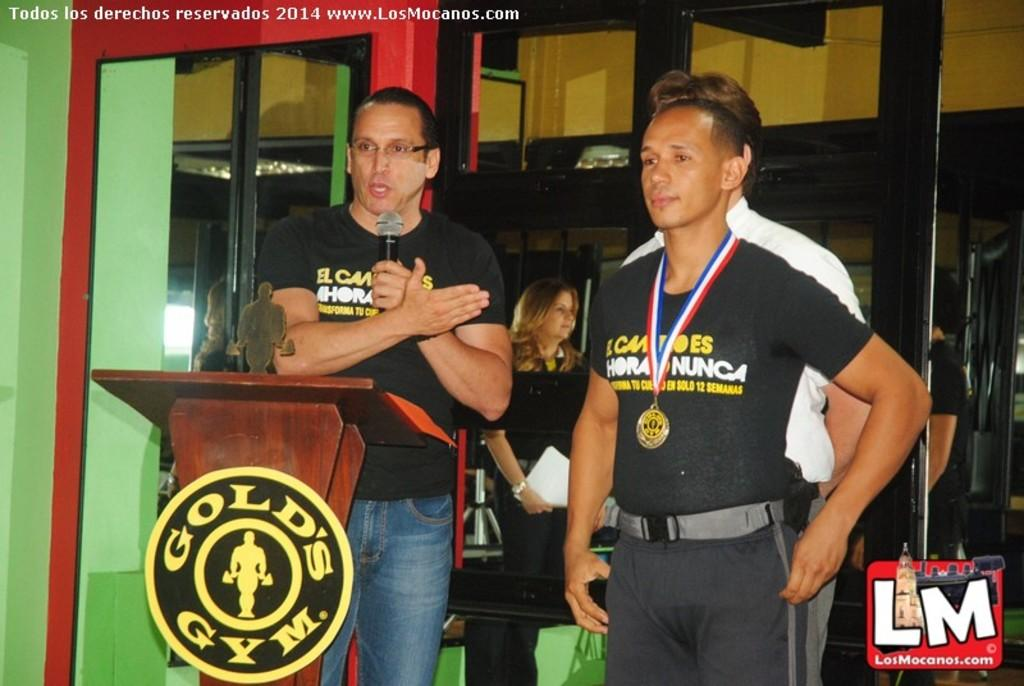<image>
Summarize the visual content of the image. man wearing medal next to someone in front of someone gold's gym podium 